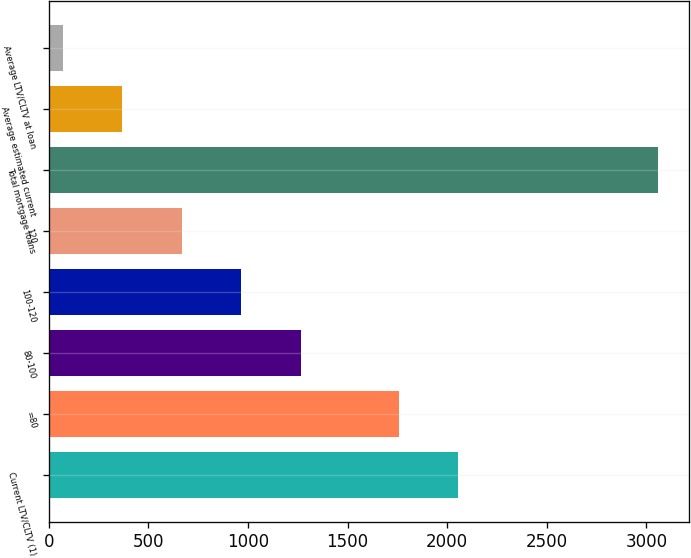Convert chart. <chart><loc_0><loc_0><loc_500><loc_500><bar_chart><fcel>Current LTV/CLTV (1)<fcel>=80<fcel>80-100<fcel>100-120<fcel>120<fcel>Total mortgage loans<fcel>Average estimated current<fcel>Average LTV/CLTV at loan<nl><fcel>2055.9<fcel>1757<fcel>1266.6<fcel>967.7<fcel>668.8<fcel>3060<fcel>369.9<fcel>71<nl></chart> 